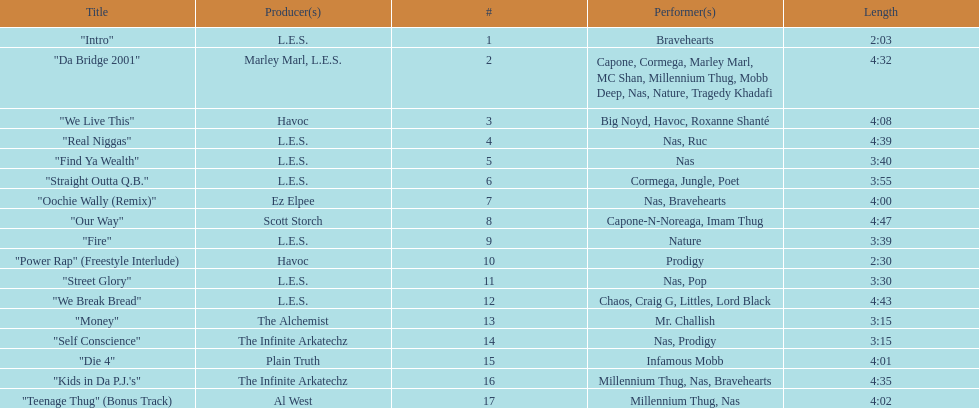After street glory, what song is listed? "We Break Bread". 